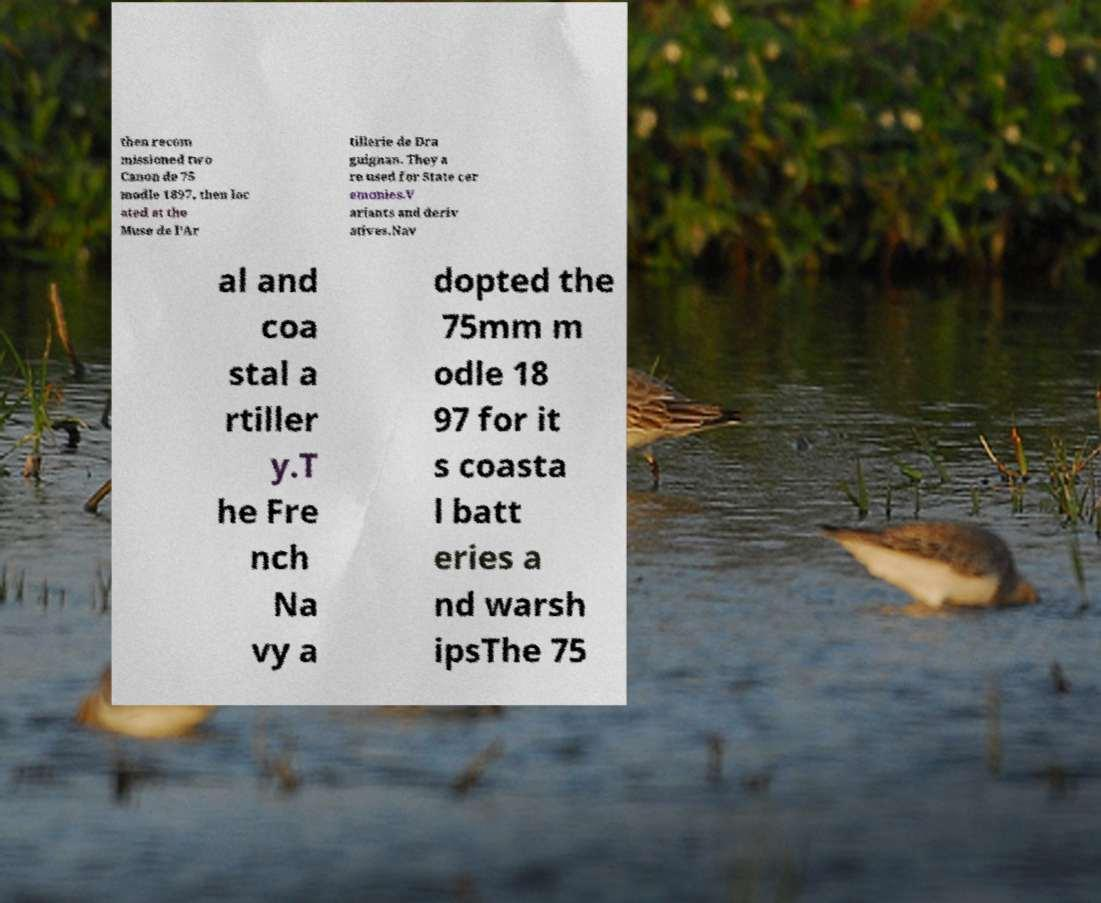Could you extract and type out the text from this image? then recom missioned two Canon de 75 modle 1897, then loc ated at the Muse de l'Ar tillerie de Dra guignan. They a re used for State cer emonies.V ariants and deriv atives.Nav al and coa stal a rtiller y.T he Fre nch Na vy a dopted the 75mm m odle 18 97 for it s coasta l batt eries a nd warsh ipsThe 75 